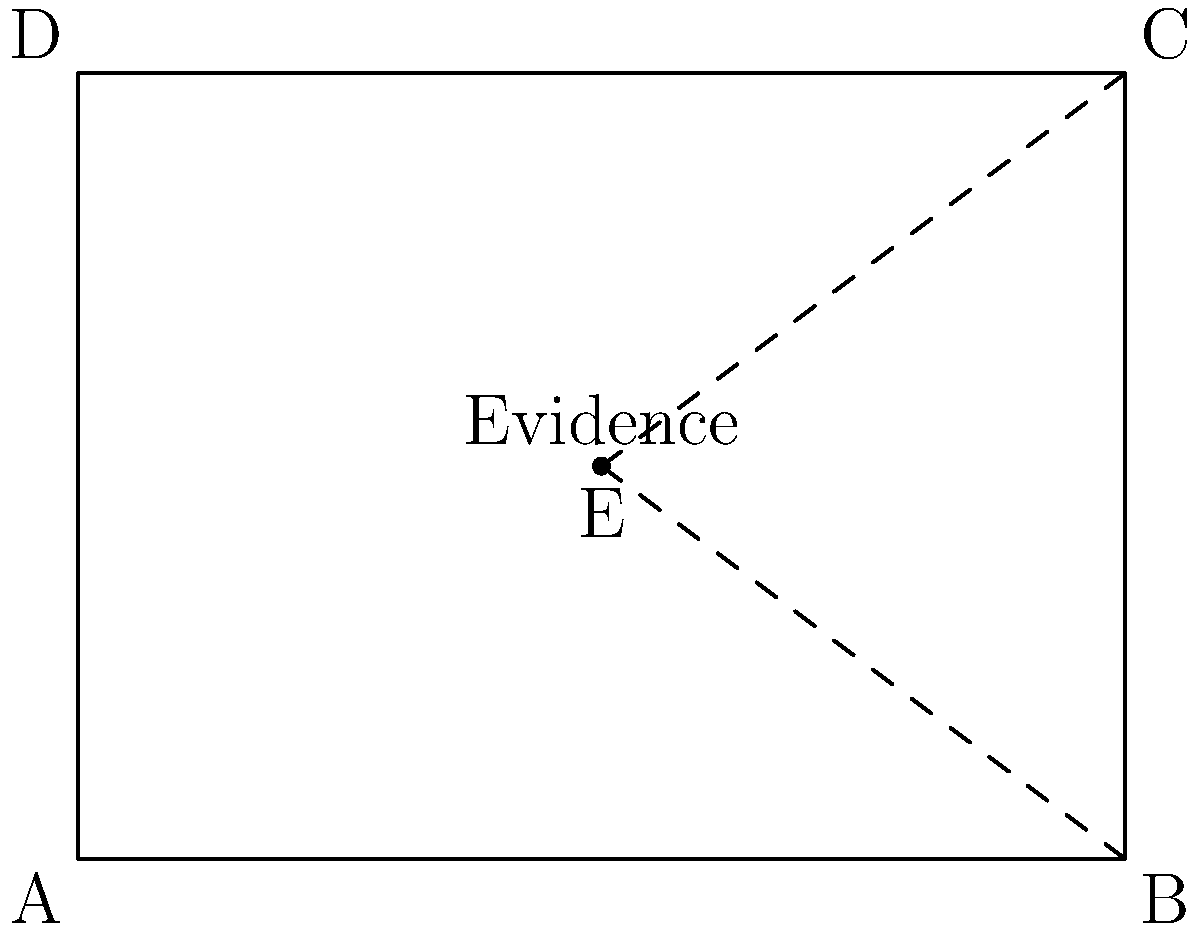In a crime scene reconstruction, a piece of crucial evidence is initially located at point E (2, 1.5) in a rectangular room ABCD. The evidence needs to be moved to point C (4, 3) to match eyewitness accounts. Describe the sequence of transformations that would represent this movement, given that the evidence must first be moved to point B (4, 0) before reaching its final position at C. To solve this problem, we need to break down the movement into two separate transformations:

1. Moving the evidence from E (2, 1.5) to B (4, 0):
   - This can be represented as a translation.
   - The translation vector is $\vec{EB} = (4-2, 0-1.5) = (2, -1.5)$
   
2. Moving the evidence from B (4, 0) to C (4, 3):
   - This is a vertical translation.
   - The translation vector is $\vec{BC} = (4-4, 3-0) = (0, 3)$

The complete transformation can be described as a composition of these two translations:

1. Translate by vector $(2, -1.5)$
2. Followed by a translation of vector $(0, 3)$

In mathematical notation, this can be written as:

$T_{(0,3)} \circ T_{(2,-1.5)}$

Where $T$ represents a translation and $\circ$ denotes composition of transformations.

This sequence of transformations accurately represents the movement of the evidence from its initial position E to its final position C, passing through point B as required.
Answer: $T_{(0,3)} \circ T_{(2,-1.5)}$ 